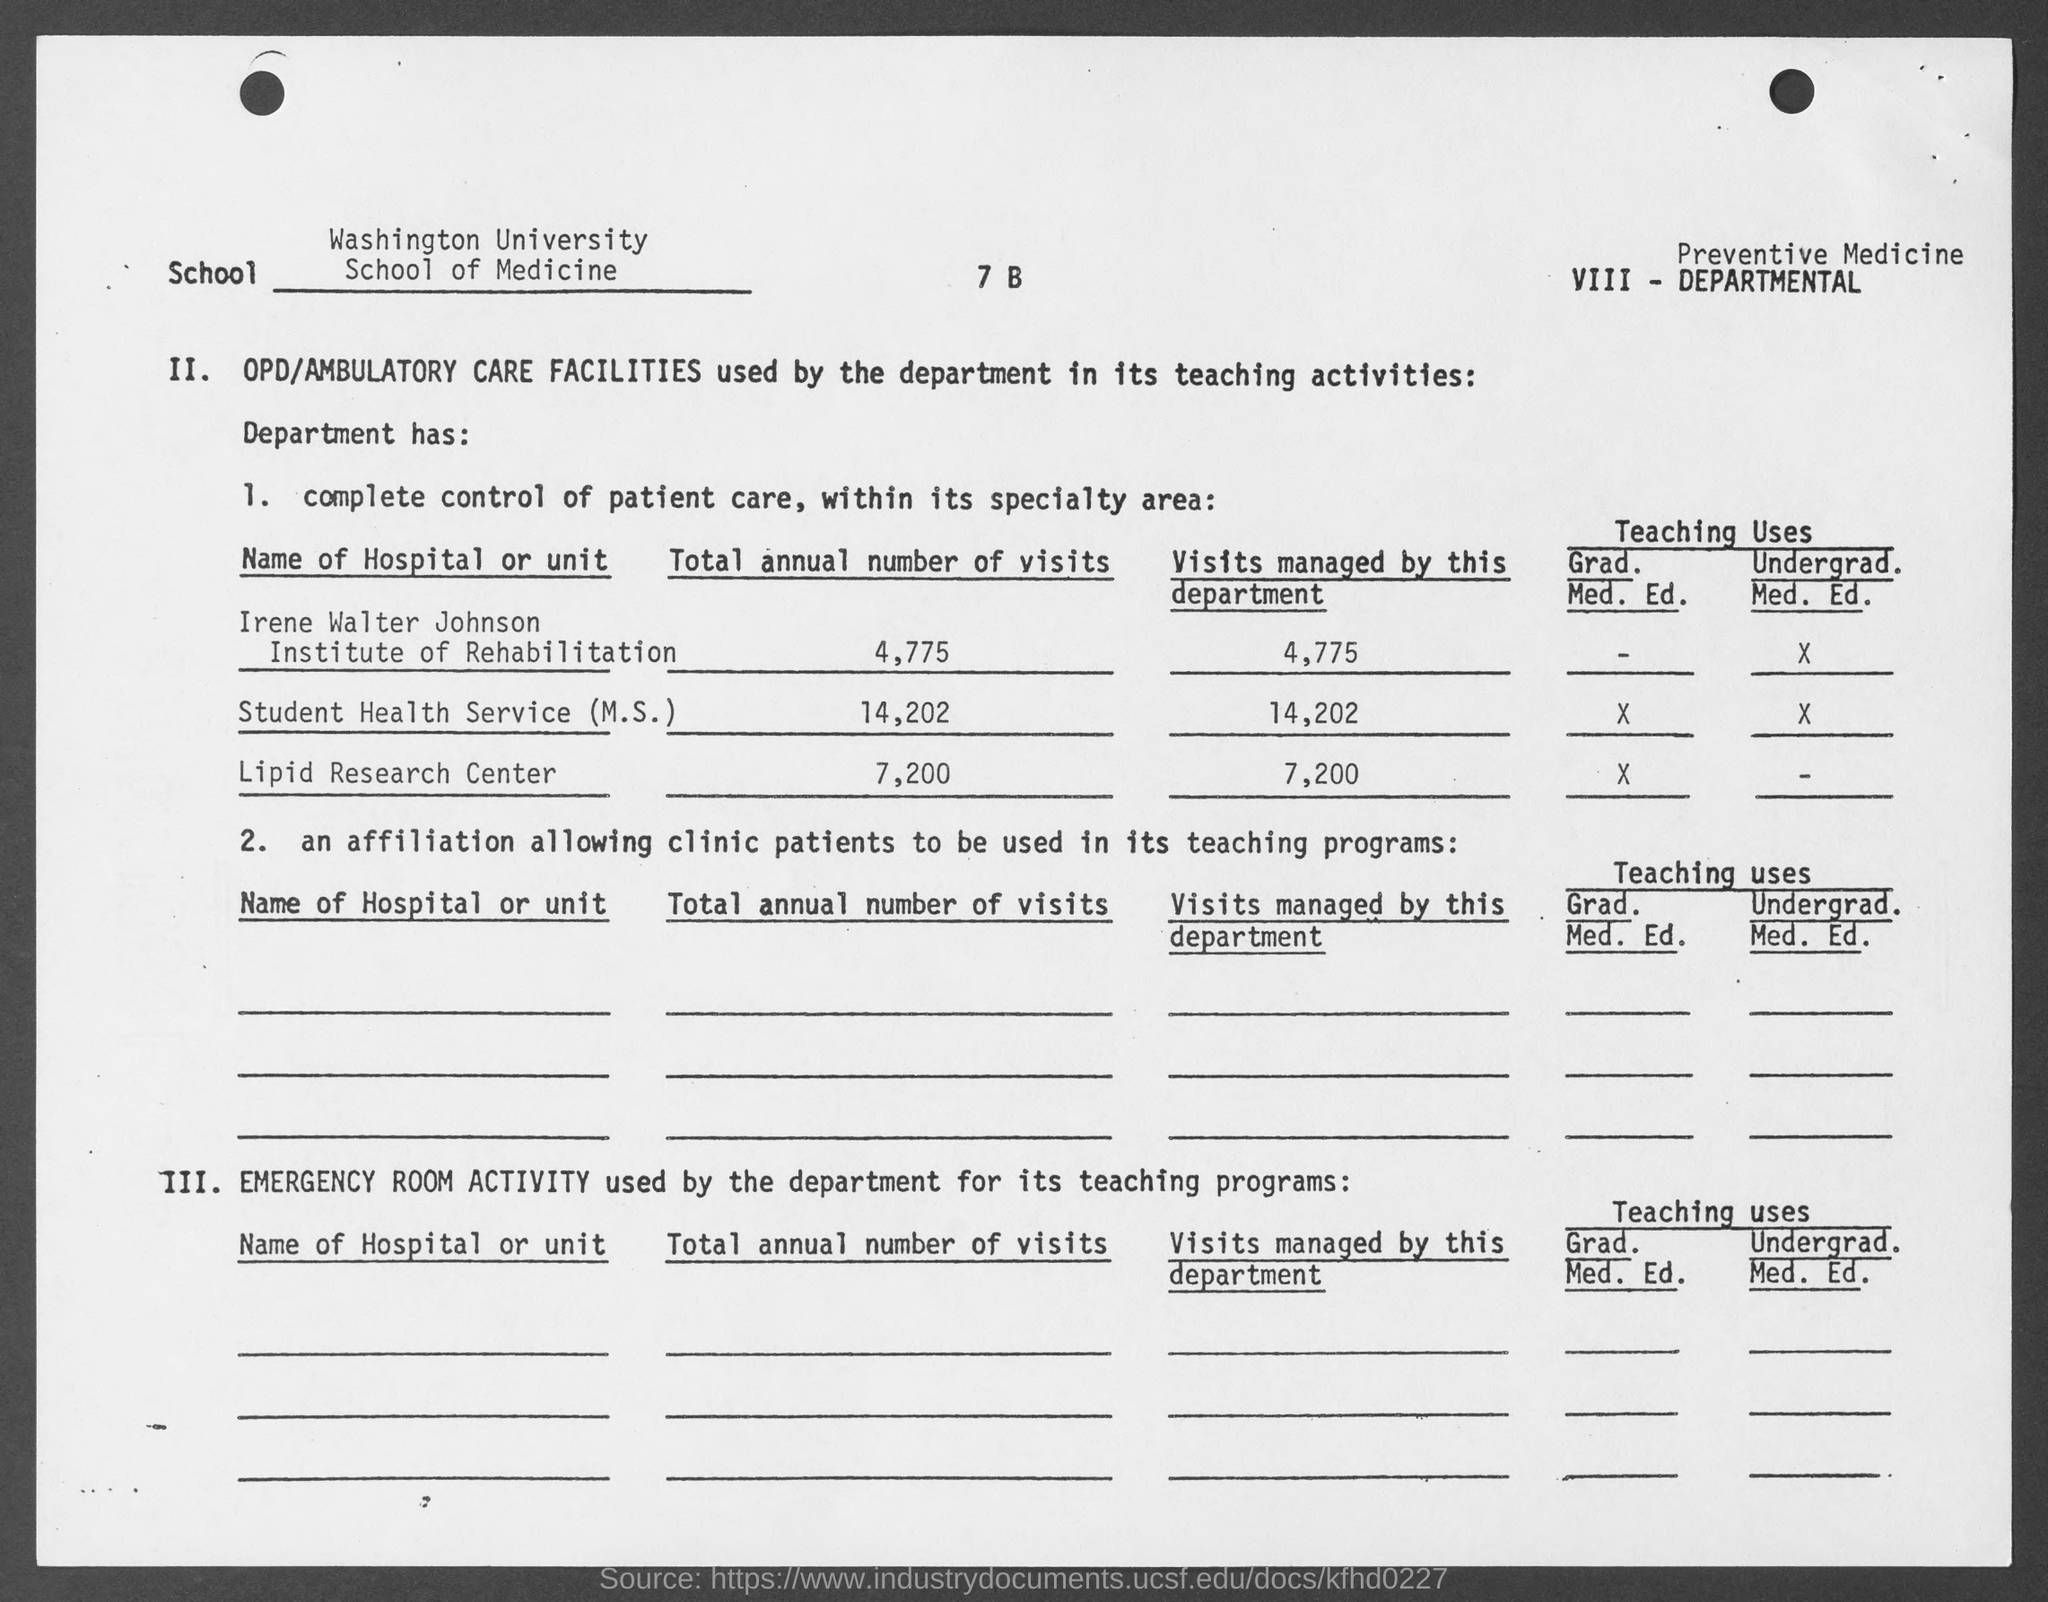Draw attention to some important aspects in this diagram. The total annual number of visits to the Lipid Research Center, as mentioned on the given page, is 7,200. The name of the school mentioned in the given page is the School of Medicine. The Irene Walter Johnson Institute of Rehabilitation had a total annual number of visits of 4,775, as mentioned on the given page. The Washington university mentioned in the given form is named. The total annual number of visits for the Student Health Service (M.S.) is 14,202, as stated on the given page. 